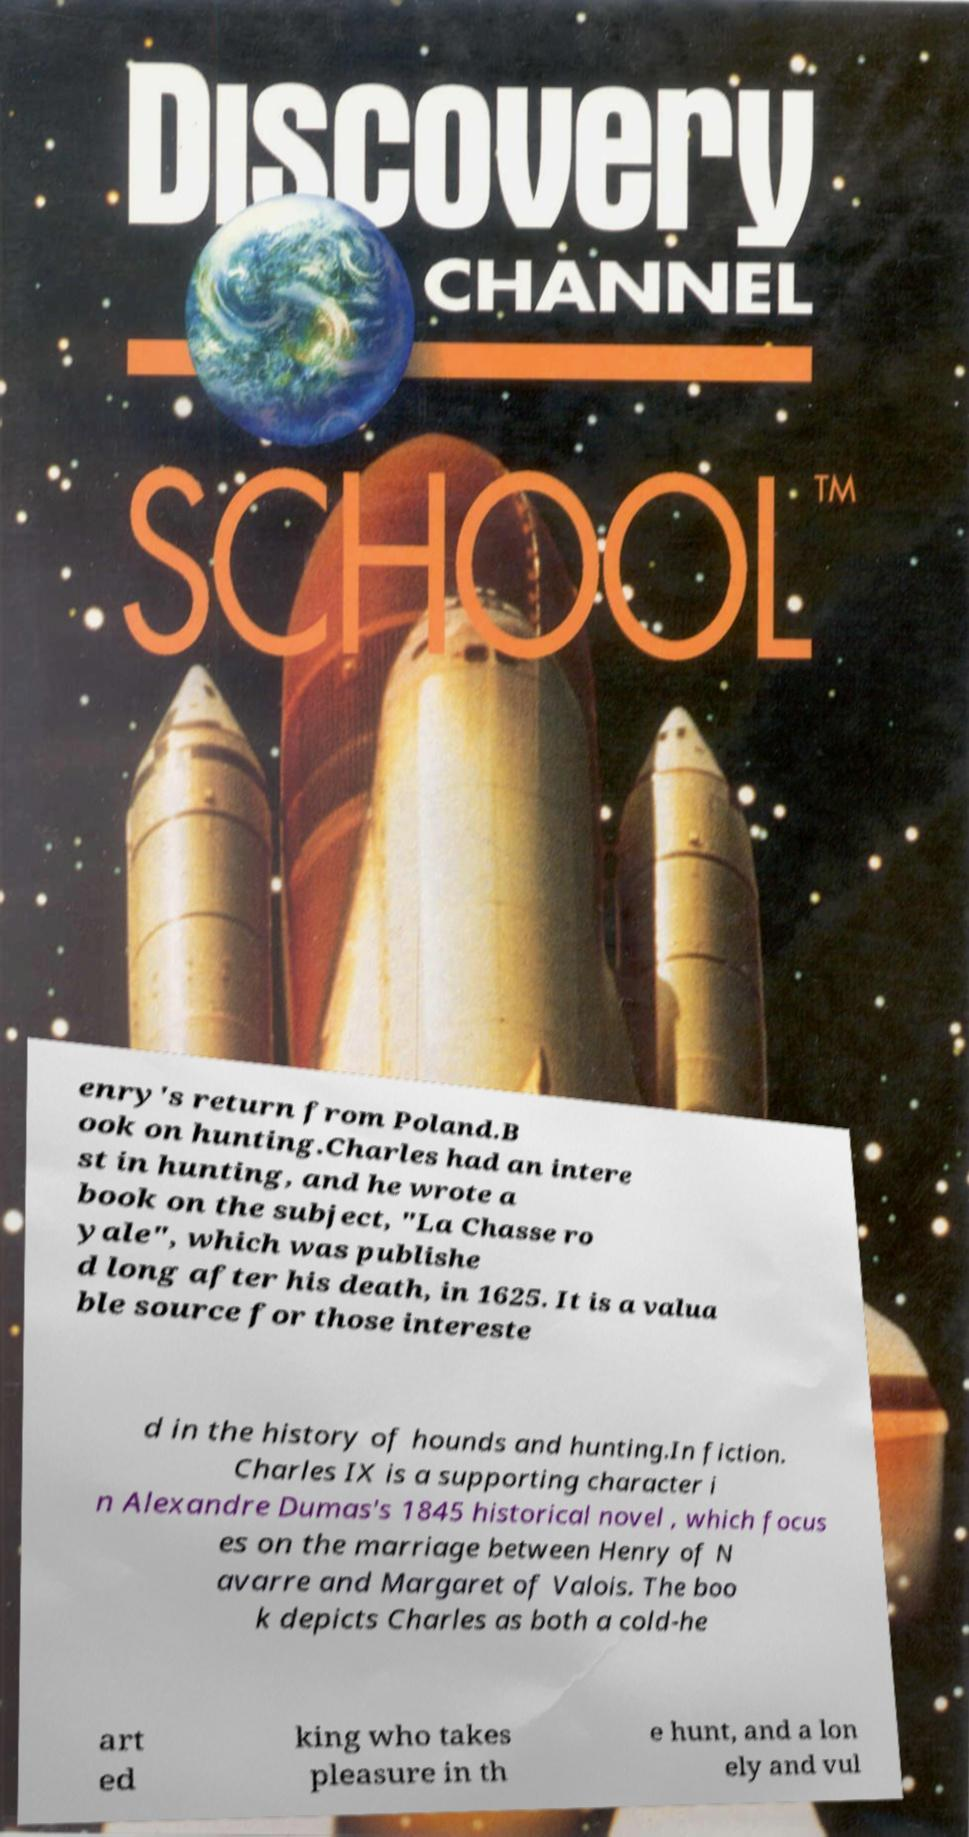Could you extract and type out the text from this image? enry's return from Poland.B ook on hunting.Charles had an intere st in hunting, and he wrote a book on the subject, "La Chasse ro yale", which was publishe d long after his death, in 1625. It is a valua ble source for those intereste d in the history of hounds and hunting.In fiction. Charles IX is a supporting character i n Alexandre Dumas's 1845 historical novel , which focus es on the marriage between Henry of N avarre and Margaret of Valois. The boo k depicts Charles as both a cold-he art ed king who takes pleasure in th e hunt, and a lon ely and vul 